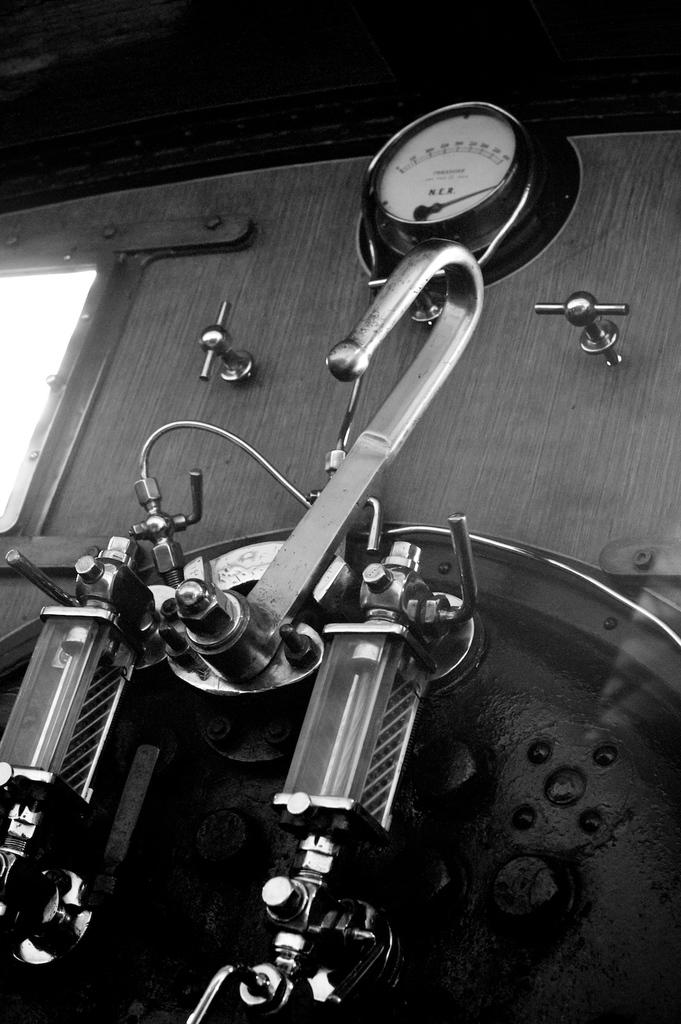What is the main object in the image? There is a machine in the image. What information can be gathered from the machine in the image? There is a meter reading in the image. What is the color scheme of the image? The image is black and white in color. What type of animal can be seen flexing its muscles in the image? There is no animal or muscle flexing in the image; it features a machine with a meter reading in a black and white color scheme. 